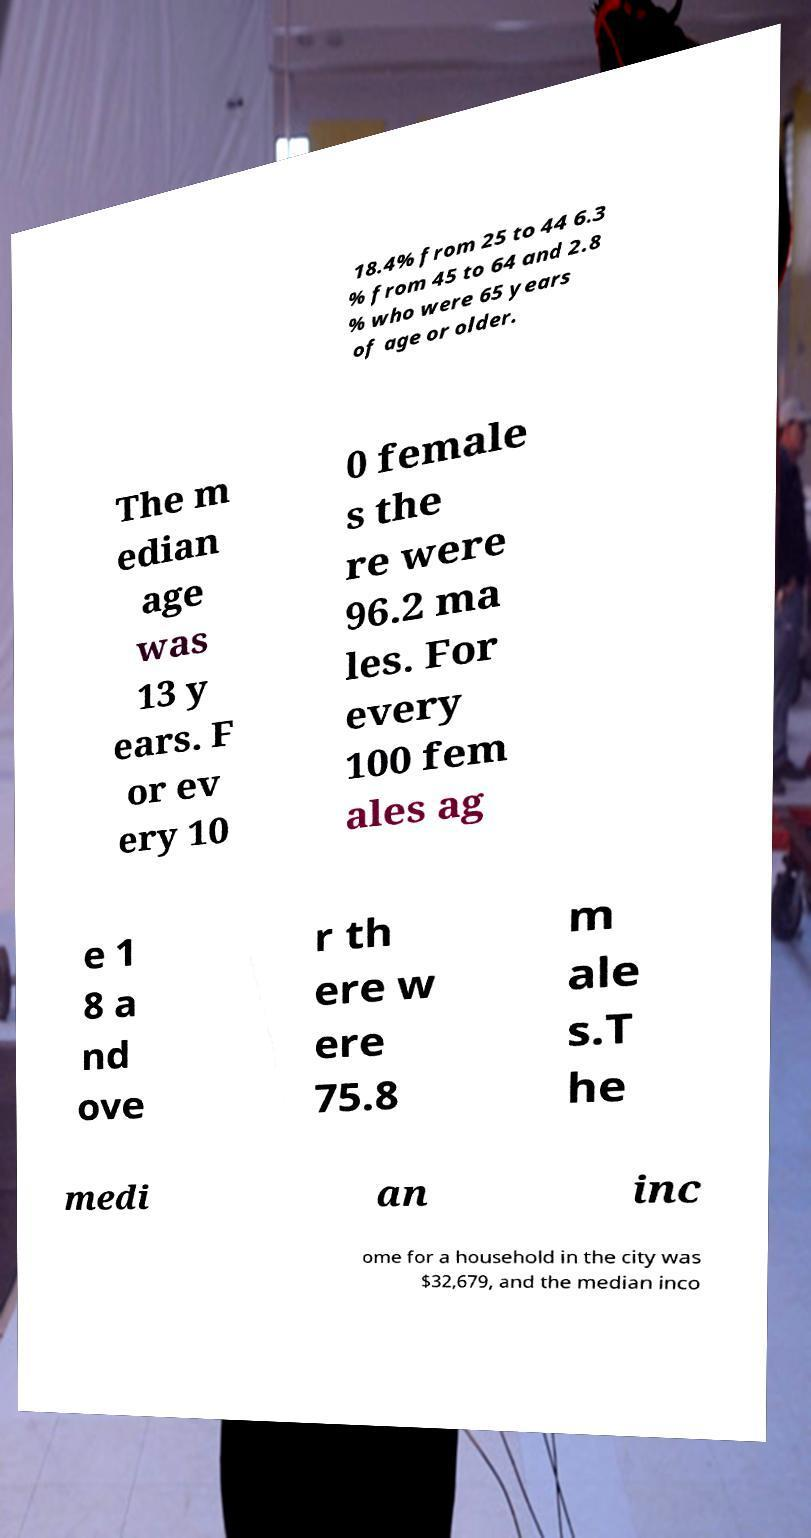What messages or text are displayed in this image? I need them in a readable, typed format. 18.4% from 25 to 44 6.3 % from 45 to 64 and 2.8 % who were 65 years of age or older. The m edian age was 13 y ears. F or ev ery 10 0 female s the re were 96.2 ma les. For every 100 fem ales ag e 1 8 a nd ove r th ere w ere 75.8 m ale s.T he medi an inc ome for a household in the city was $32,679, and the median inco 